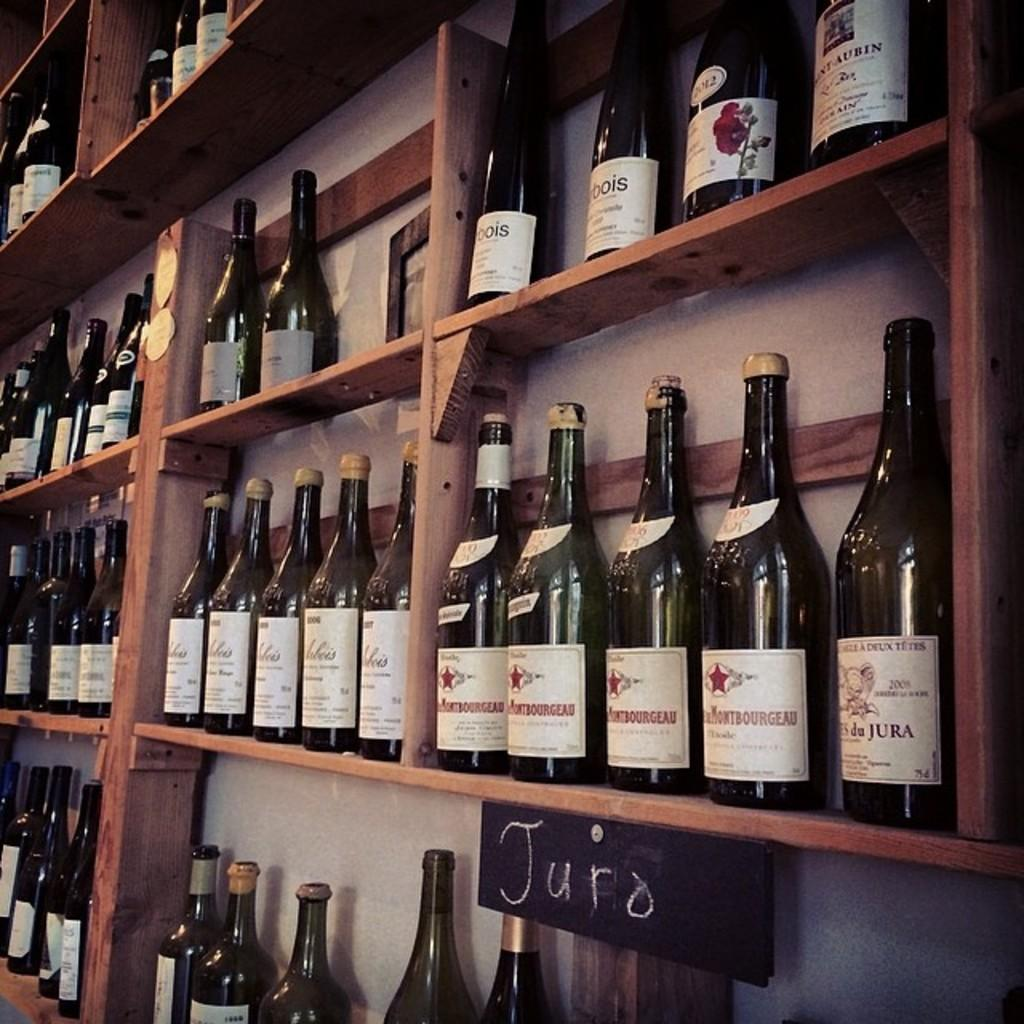Provide a one-sentence caption for the provided image. wines are sitting on wooden shelves and one shelf is labeled Juro. 